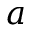<formula> <loc_0><loc_0><loc_500><loc_500>a</formula> 